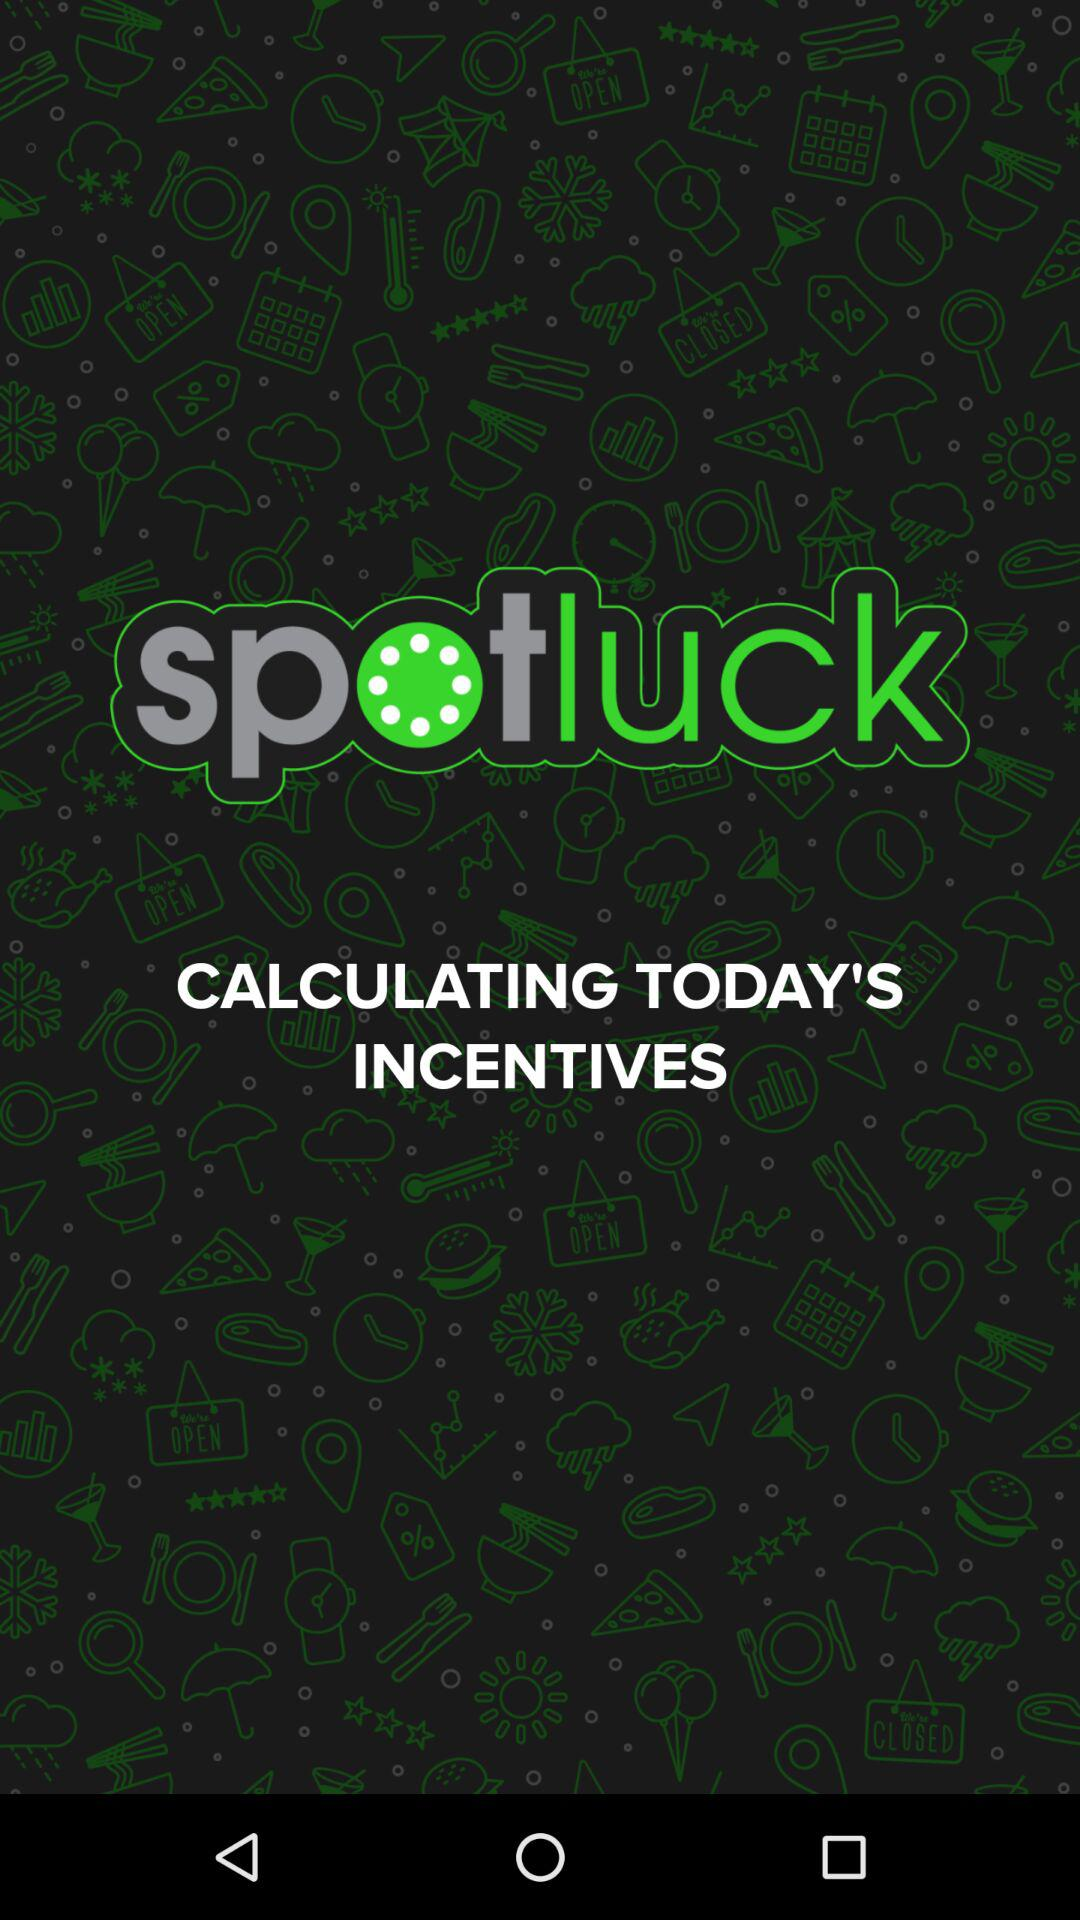What is the application name? The application name is "spotluck". 